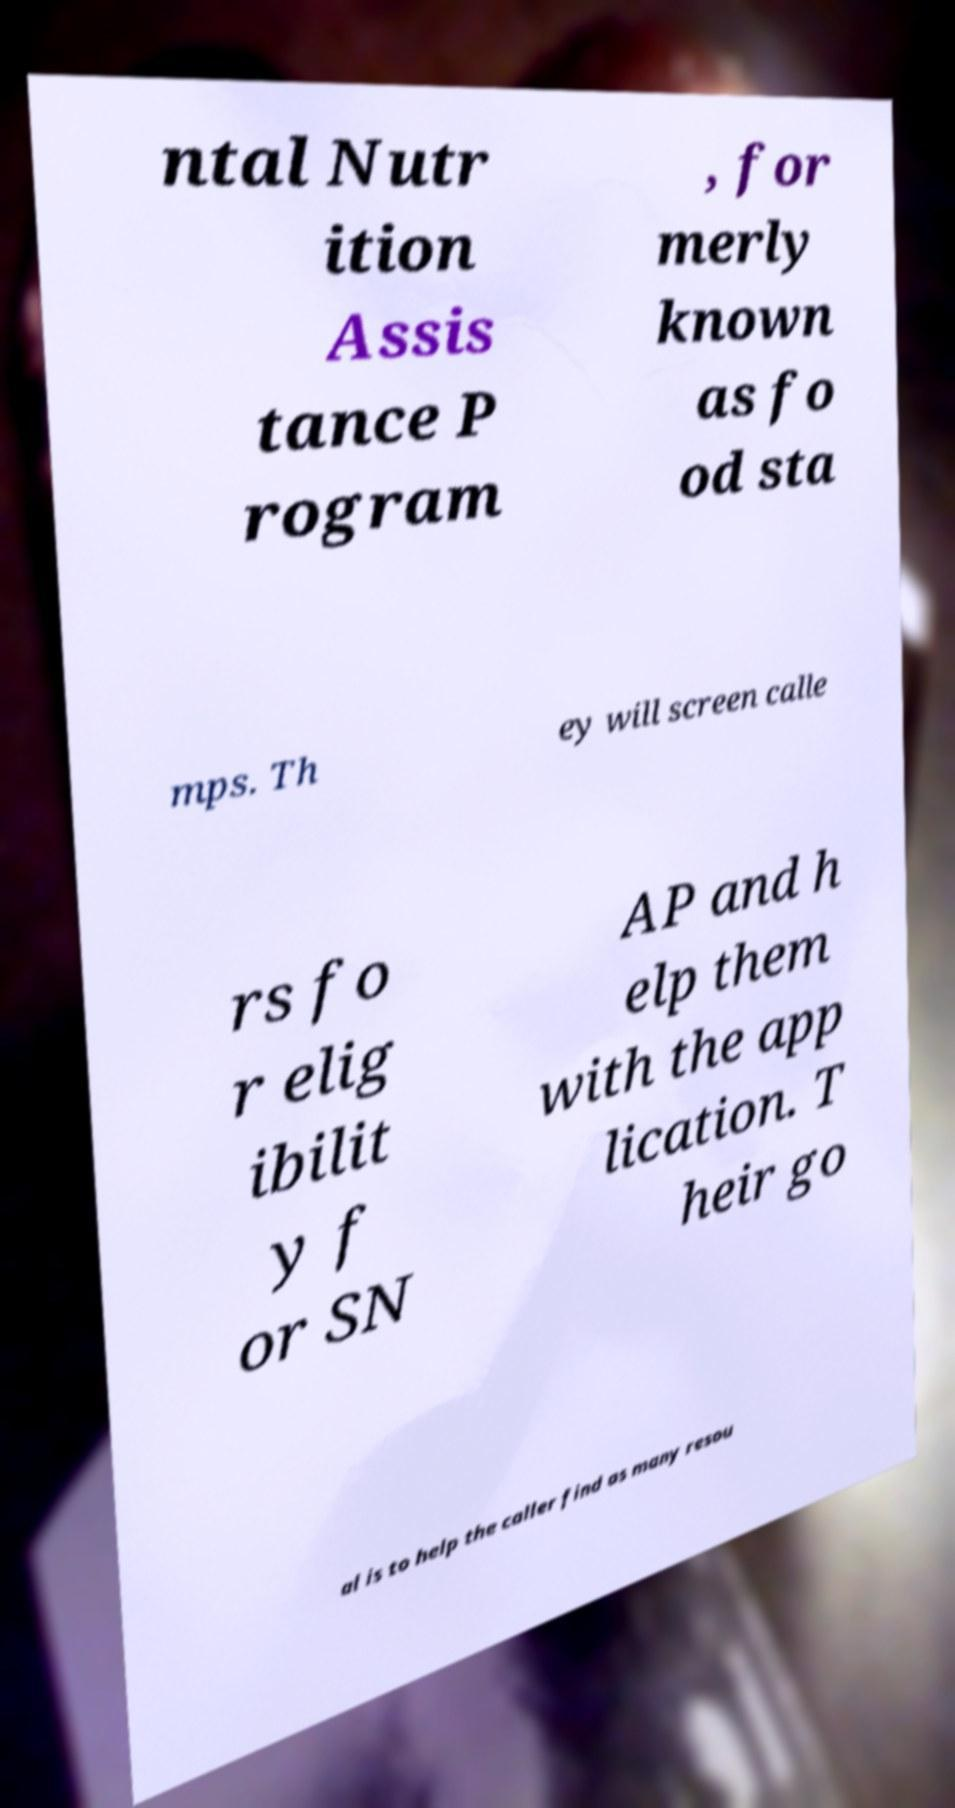For documentation purposes, I need the text within this image transcribed. Could you provide that? ntal Nutr ition Assis tance P rogram , for merly known as fo od sta mps. Th ey will screen calle rs fo r elig ibilit y f or SN AP and h elp them with the app lication. T heir go al is to help the caller find as many resou 